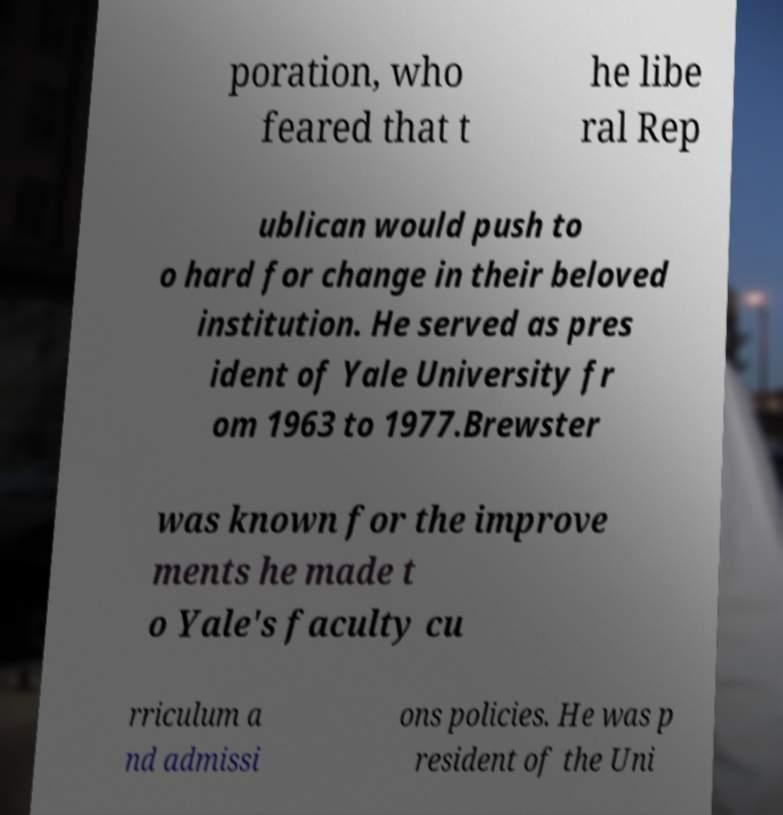Please read and relay the text visible in this image. What does it say? poration, who feared that t he libe ral Rep ublican would push to o hard for change in their beloved institution. He served as pres ident of Yale University fr om 1963 to 1977.Brewster was known for the improve ments he made t o Yale's faculty cu rriculum a nd admissi ons policies. He was p resident of the Uni 